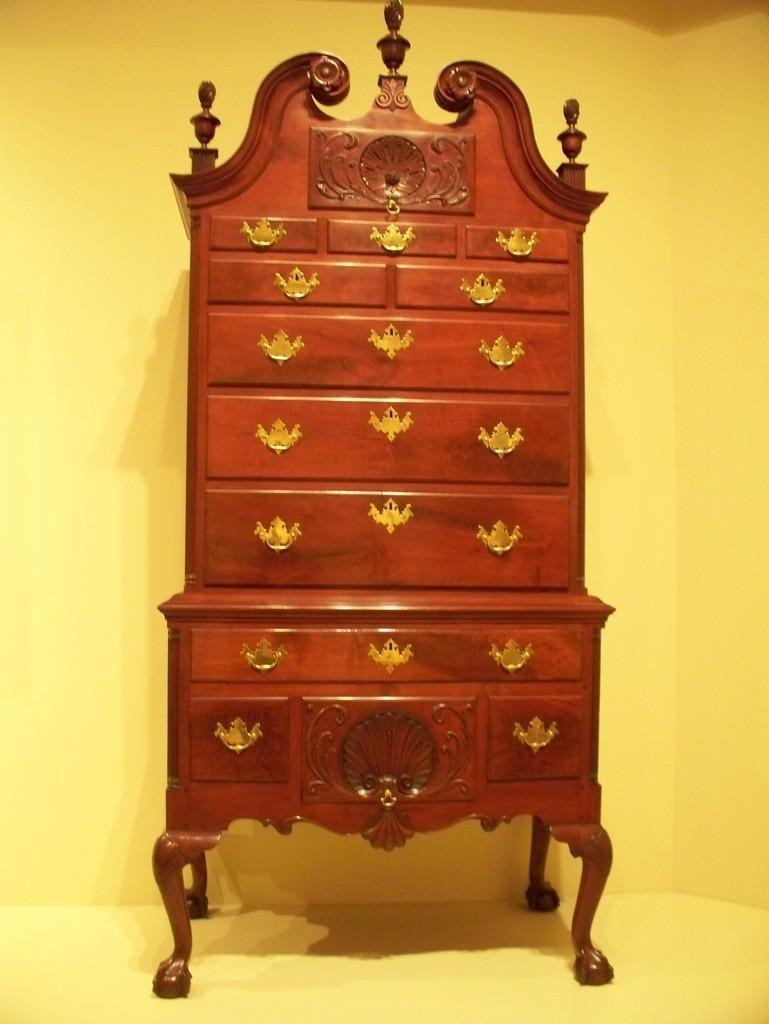Could you give a brief overview of what you see in this image? Here we can see a table and there is a yellow color background. 